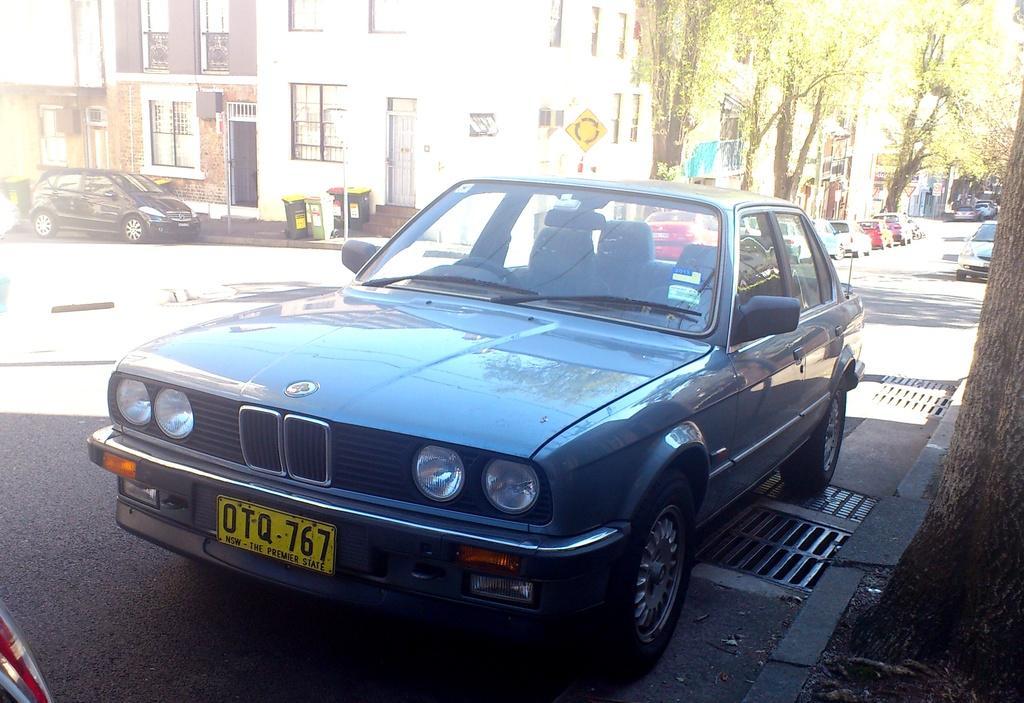How would you summarize this image in a sentence or two? In this picture there are vehicles on the road and there are buildings and trees and there are poles and there are dustbins. At the bottom there is a road and there are manholes on the road. 